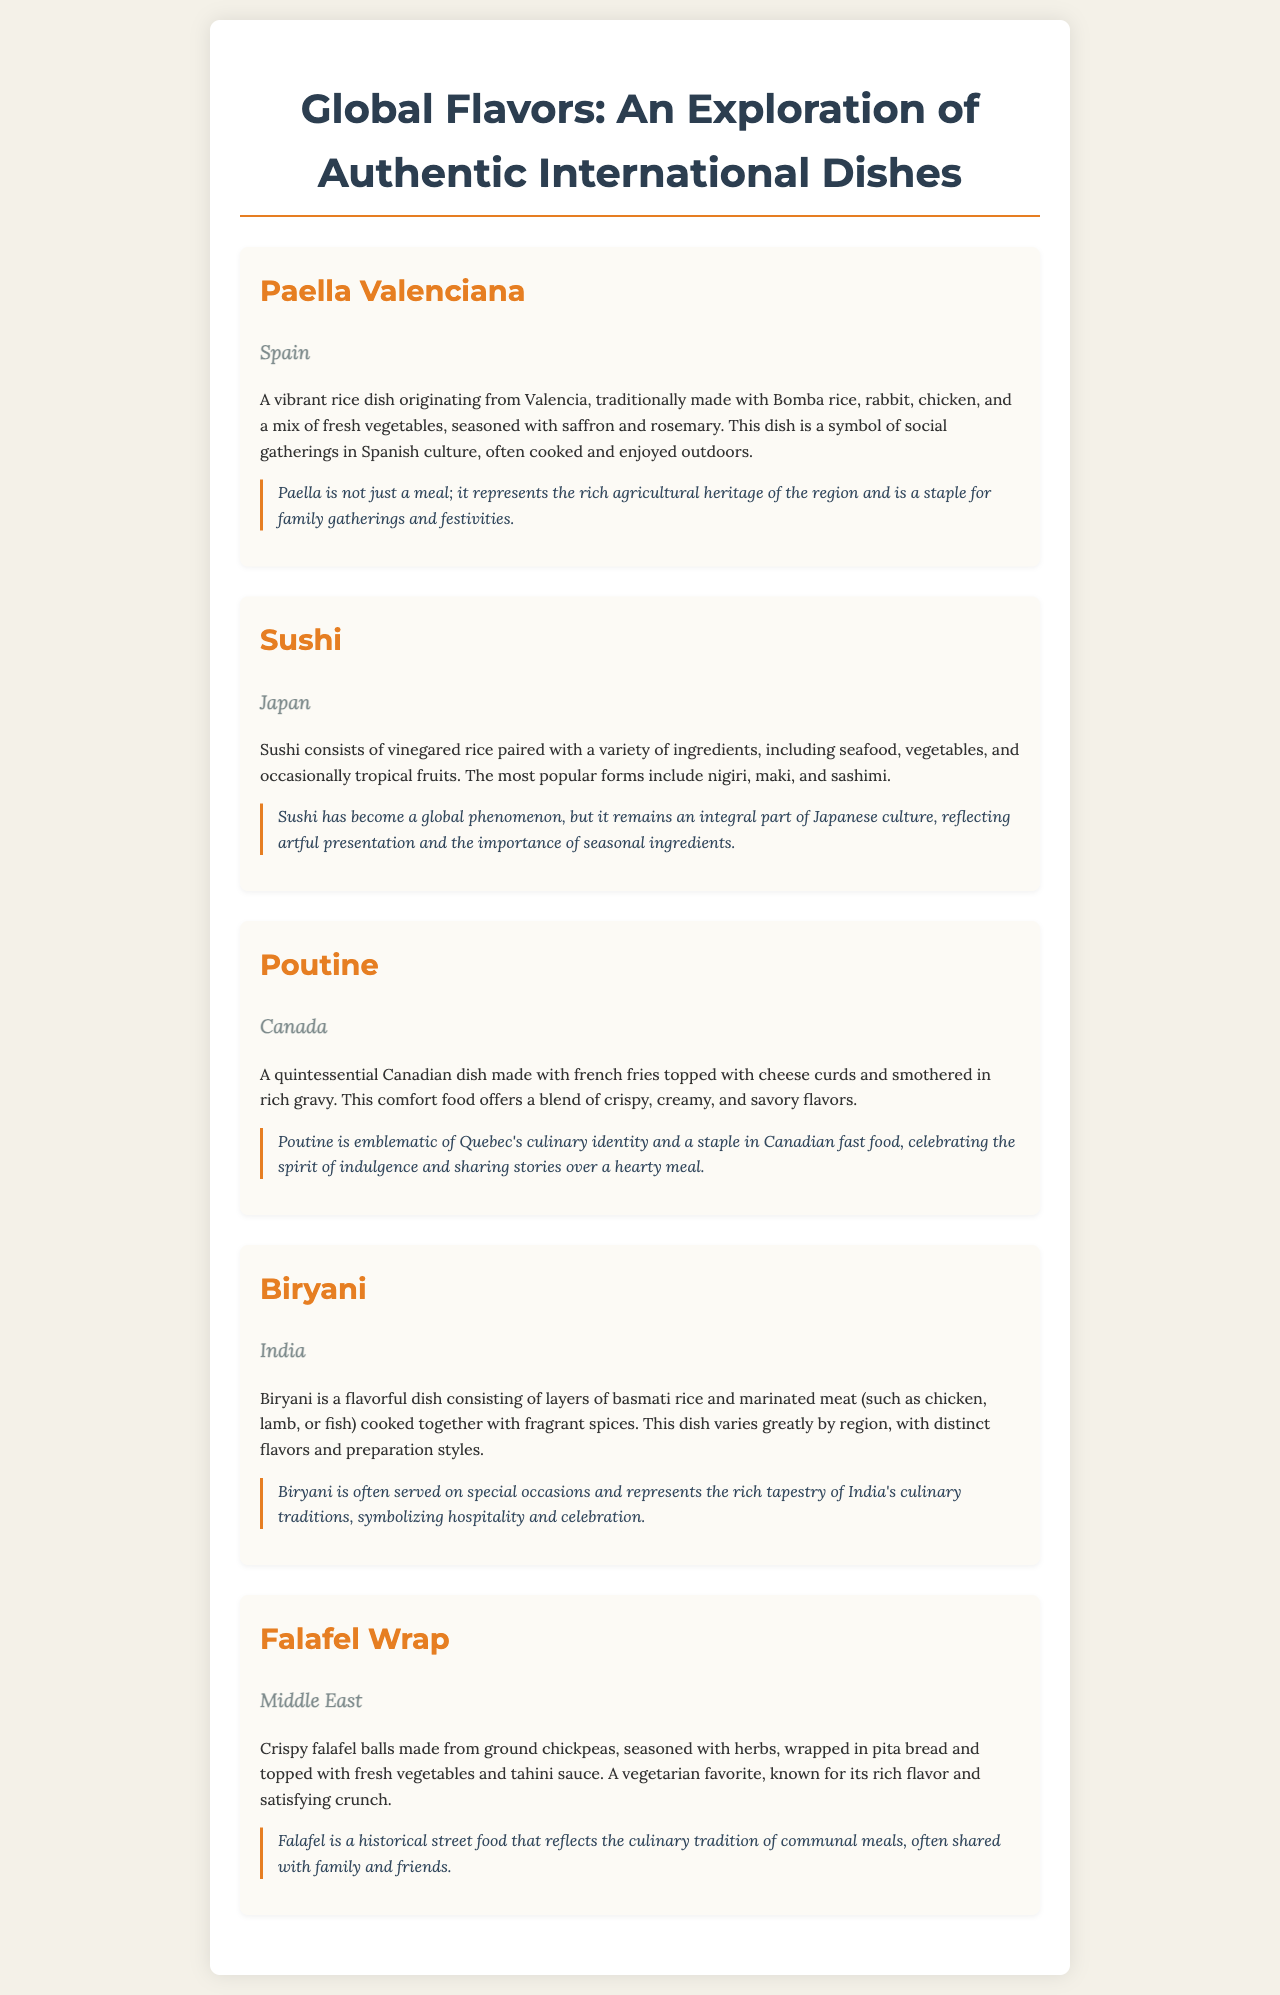What is the first dish listed? The first dish listed in the menu is "Paella Valenciana."
Answer: Paella Valenciana Which country is associated with Sushi? The dish Sushi is associated with Japan.
Answer: Japan What are the main ingredients of Poutine? Poutine is made with french fries, cheese curds, and gravy.
Answer: French fries, cheese curds, gravy Which dish is described as a vegetarian favorite? The dish described as a vegetarian favorite is the "Falafel Wrap."
Answer: Falafel Wrap How is Biryani typically served? Biryani is often served on special occasions.
Answer: Special occasions What does Paella symbolize in Spanish culture? Paella symbolizes social gatherings in Spanish culture.
Answer: Social gatherings What flavors characterize the Biryani dish? Biryani is characterized by fragrant spices and marinated meat.
Answer: Fragrant spices, marinated meat Which dish represents Quebec's culinary identity? The dish that represents Quebec's culinary identity is "Poutine."
Answer: Poutine 